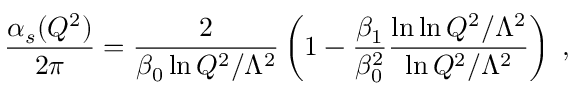<formula> <loc_0><loc_0><loc_500><loc_500>\frac { \alpha _ { s } ( Q ^ { 2 } ) } { 2 \pi } = \frac { 2 } { \beta _ { 0 } \ln Q ^ { 2 } / \Lambda ^ { 2 } } \left ( 1 - \frac { \beta _ { 1 } } { \beta _ { 0 } ^ { 2 } } \frac { \ln \ln Q ^ { 2 } / \Lambda ^ { 2 } } { \ln Q ^ { 2 } / \Lambda ^ { 2 } } \right ) \, ,</formula> 